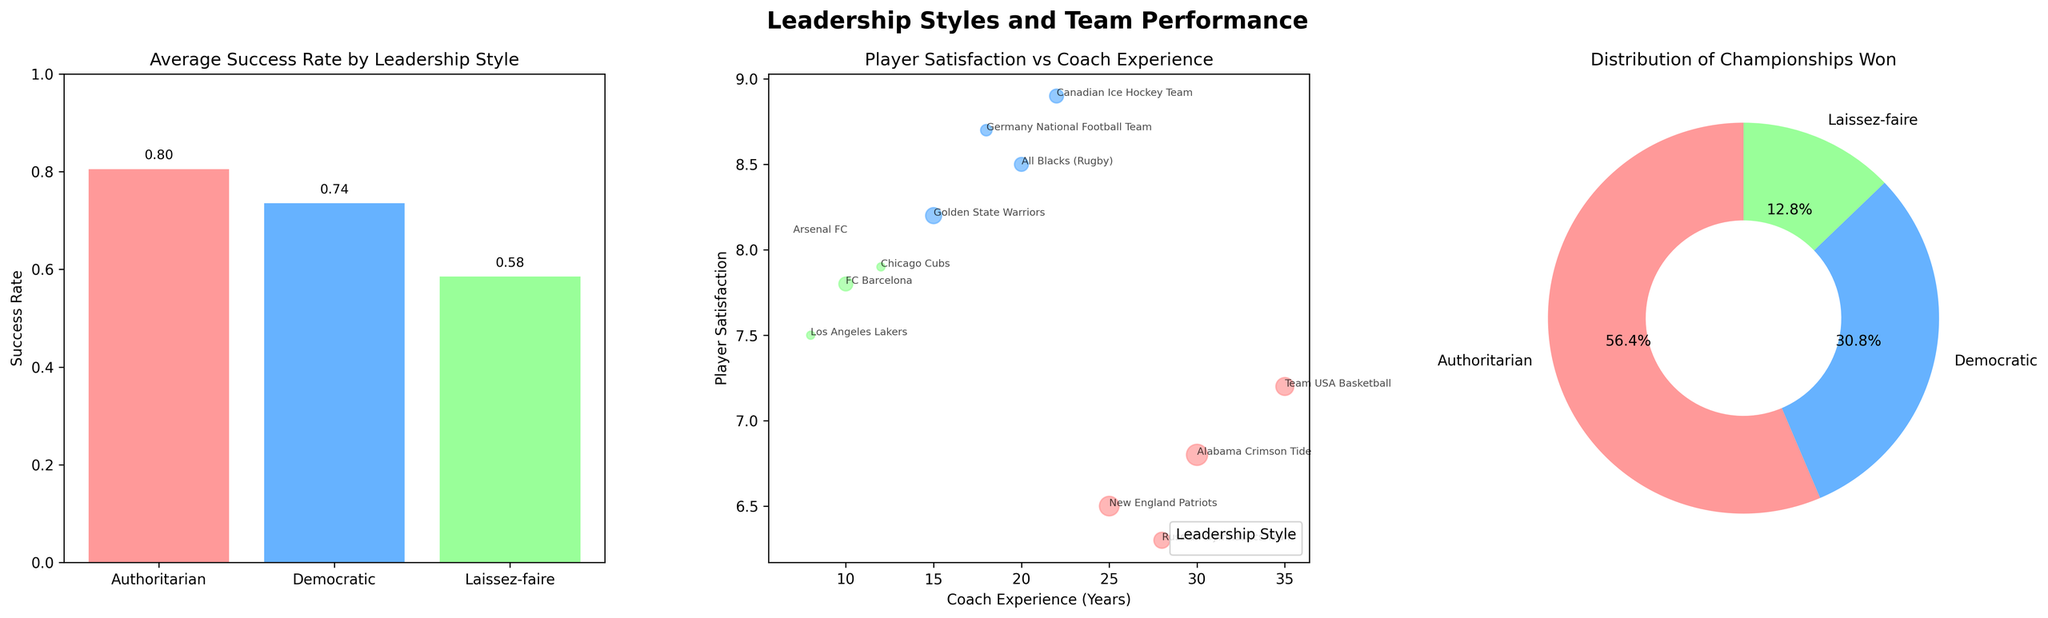What's the title of the bar plot? The title of the bar plot can be found directly above the bars, centered within the plot. It reads "Average Success Rate by Leadership Style."
Answer: Average Success Rate by Leadership Style What is the success rate for the authoritarian leadership style? To find this, look at the height of the bar representing the authoritarian leadership style and check the label above it. It shows a value of approximately 0.80.
Answer: 0.80 Which leadership style has the highest player satisfaction? In the scatter plot, observe the y-axis (Player Satisfaction) and check for the highest data points. The blue points (Democratic) appear to have the highest player satisfaction, specifically highlighted by the All Blacks team.
Answer: Democratic What is the average success rate for laissez-faire leadership style? Look at the height of the bar representing the laissez-faire style in the first subplot and read the label above the bar. It states the value is approximately 0.58.
Answer: 0.58 Which team has the highest combination of player satisfaction and coach experience? In the scatter plot, look for the data point that is highest on both the x-axis (Coach Experience) and the y-axis (Player Satisfaction). The point representing the Canadian Ice Hockey Team shows the highest player satisfaction and solid coach experience.
Answer: Canadian Ice Hockey Team How many championships were won by teams with authoritarian leadership? For this, refer to the pie chart and look at the portion labeled for authoritarian style. The precise count can be calculated by summing up the respective values represented, which are 6 + 7 + 5 + 4 = 22.
Answer: 22 Which leadership style won the least number of championships? In the pie chart, observe the portions corresponding to each leadership style and find the smallest one. The wedge labeled laissez-faire represents the smallest portion.
Answer: Laissez-faire Compare the success rates between democratic and laissez-faire leadership styles. Observe the heights of the bars in the bar plot. The bar for democratic shows approximately 0.74, and the laissez-faire style shows approximately 0.58. Thus, the democratic style has a higher success rate.
Answer: Democratic has a higher success rate than laissez-faire What does each bubble in the scatter plot represent? Each bubble represents a team. Its size reflects the number of championships won, while its position shows the team's player satisfaction vs. coach experience. The color indicates the team's leadership style.
Answer: Each bubble represents a team, indicating player satisfaction, coach experience, and championships won 